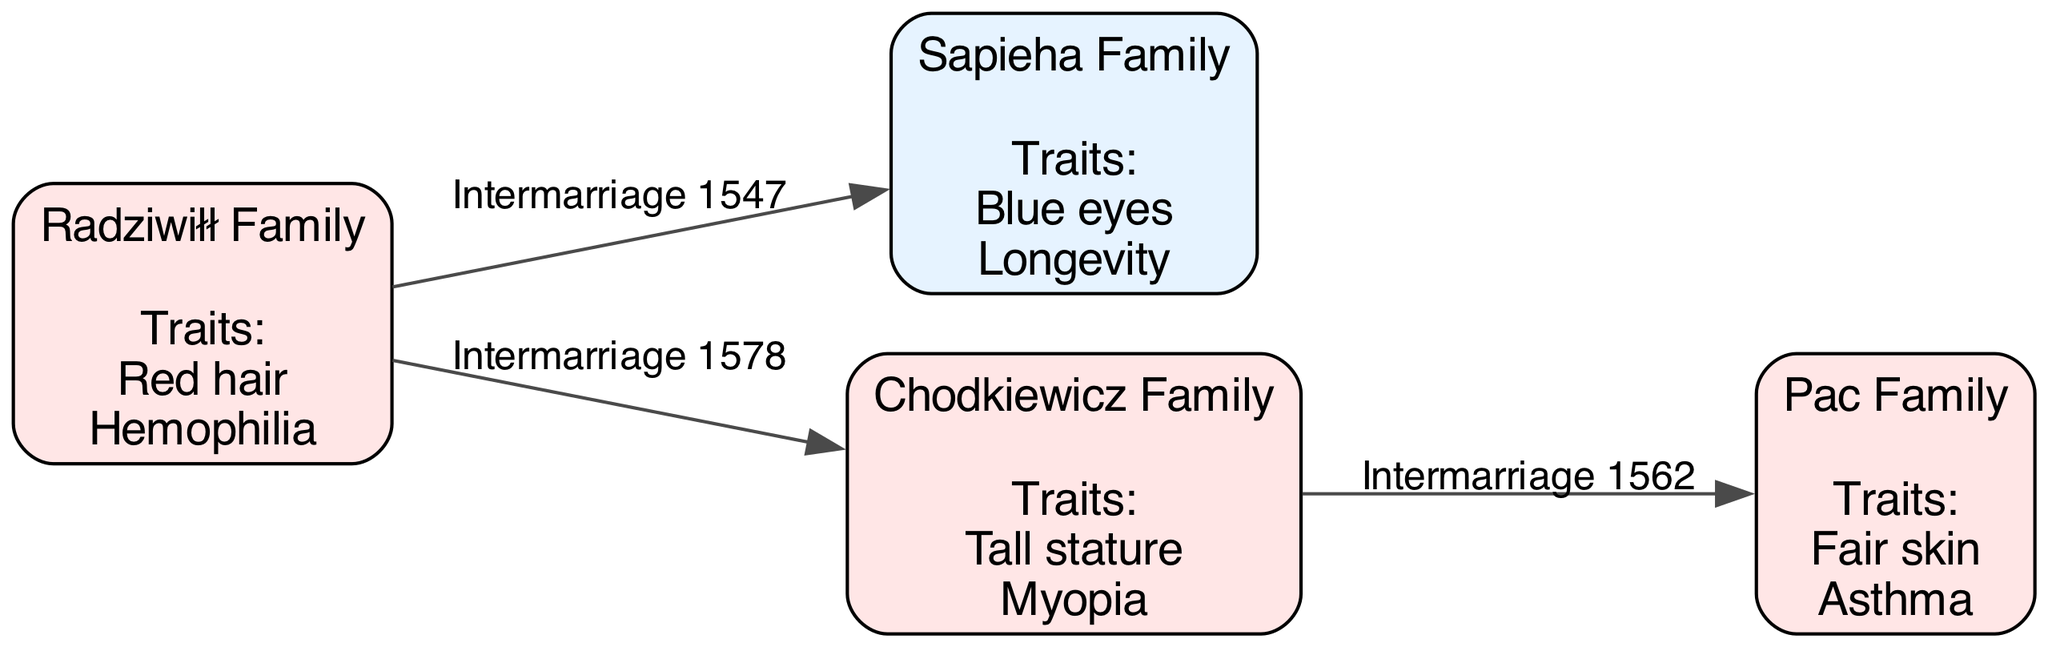What is the total number of noble families represented in the diagram? The diagram lists four distinct families: Radziwiłł, Sapieha, Chodkiewicz, and Pac. Counting each of these gives a total of four families.
Answer: 4 Which family has the hereditary trait of hemophilia? By examining the traits listed under each family, the Radziwiłł Family is noted to have hemophilia as one of their hereditary traits.
Answer: Radziwiłł Family What type of intermarriage occurred between the Radziwiłł Family and the Sapieha Family? The diagram shows an edge labeled "Intermarriage 1547" connecting the Radziwiłł Family and the Sapieha Family, indicating that they intermarried in that year.
Answer: Intermarriage 1547 Which family exhibits the trait of myopia? The Chodkiewicz Family is listed with "Myopia" as one of its hereditary traits, making it the family that exhibits this condition.
Answer: Chodkiewicz Family How many intermarriages are depicted in the diagram? There are three edges represented in the diagram, each indicating an intermarriage between the families. Counting these edges gives a total of three intermarriages.
Answer: 3 What common trait do the Sapieha Family and the Radziwiłł Family share? Analyzing the traits listed for the two families, neither shares a common hereditary trait; Sapieha has blue eyes and longevity, while Radziwiłł has red hair and hemophilia.
Answer: None Which family is associated with asthma? The Pac Family has "Asthma" listed as one of their hereditary traits, which identifies this family as being associated with the condition.
Answer: Pac Family Which family intermarried with Chodkiewicz in 1562? According to the diagram, the edge labeled "Intermarriage 1562" connects Chodkiewicz and Pac, indicating that the Pac Family intermarried with Chodkiewicz in that year.
Answer: Pac Family What trait does the Pac Family exhibit relating to skin? The traits listed for the Pac Family include "Fair skin," which describes their hereditary trait concerning skin.
Answer: Fair skin 